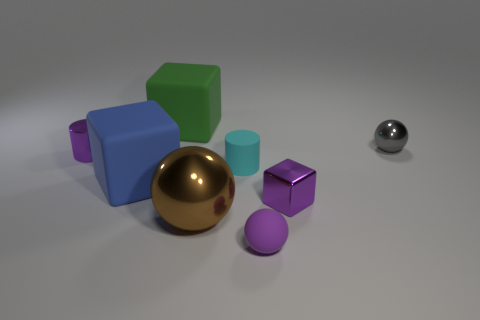There is a ball that is behind the purple shiny object on the left side of the tiny purple matte sphere; what is it made of?
Keep it short and to the point. Metal. What size is the blue matte object?
Your response must be concise. Large. What number of brown metallic spheres are the same size as the purple metallic cylinder?
Provide a short and direct response. 0. How many tiny gray objects are the same shape as the blue object?
Give a very brief answer. 0. Are there the same number of tiny rubber objects to the right of the small cyan cylinder and large green blocks?
Give a very brief answer. Yes. What is the shape of the green rubber object that is the same size as the brown object?
Provide a succinct answer. Cube. Are there any purple metal objects that have the same shape as the large green rubber thing?
Keep it short and to the point. Yes. There is a metallic ball to the left of the small ball behind the purple block; is there a big rubber thing behind it?
Keep it short and to the point. Yes. Are there more metallic cubes that are to the right of the gray sphere than metal spheres behind the metallic cube?
Make the answer very short. No. What is the material of the purple cylinder that is the same size as the gray thing?
Ensure brevity in your answer.  Metal. 